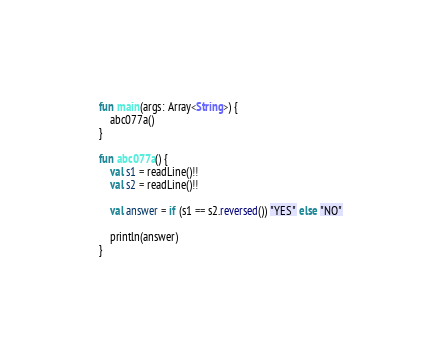<code> <loc_0><loc_0><loc_500><loc_500><_Kotlin_>fun main(args: Array<String>) {
    abc077a()
}

fun abc077a() {
    val s1 = readLine()!!
    val s2 = readLine()!!

    val answer = if (s1 == s2.reversed()) "YES" else "NO"

    println(answer)
}
</code> 